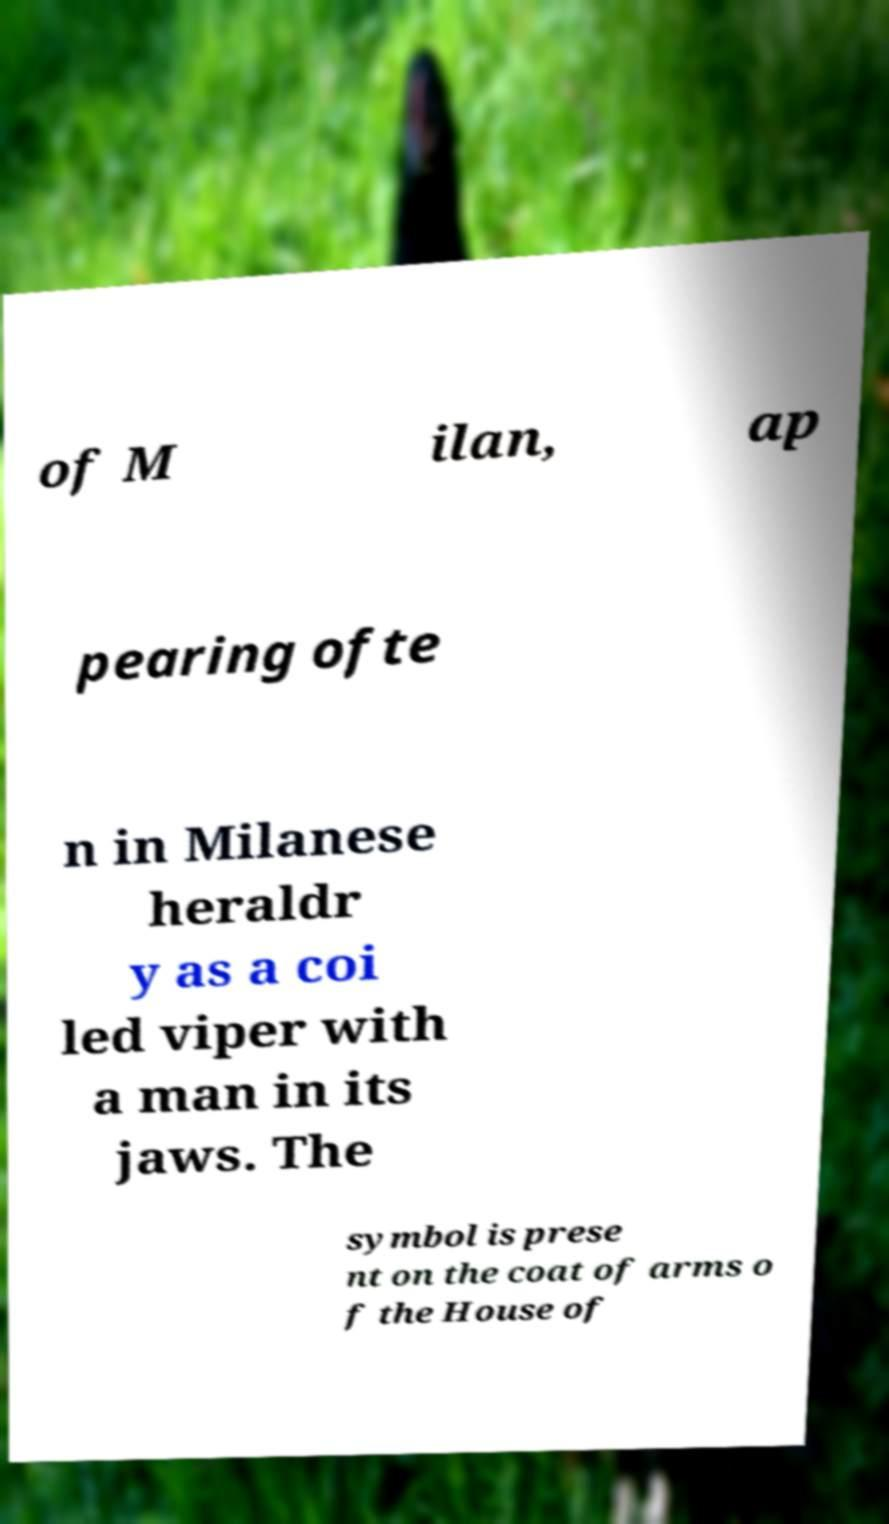Can you read and provide the text displayed in the image?This photo seems to have some interesting text. Can you extract and type it out for me? of M ilan, ap pearing ofte n in Milanese heraldr y as a coi led viper with a man in its jaws. The symbol is prese nt on the coat of arms o f the House of 